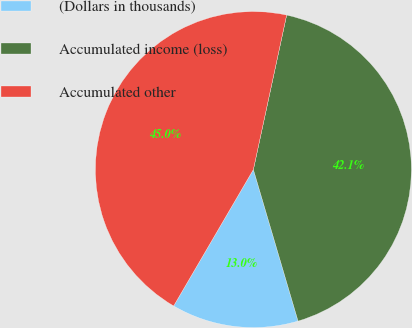Convert chart to OTSL. <chart><loc_0><loc_0><loc_500><loc_500><pie_chart><fcel>(Dollars in thousands)<fcel>Accumulated income (loss)<fcel>Accumulated other<nl><fcel>12.98%<fcel>42.06%<fcel>44.96%<nl></chart> 